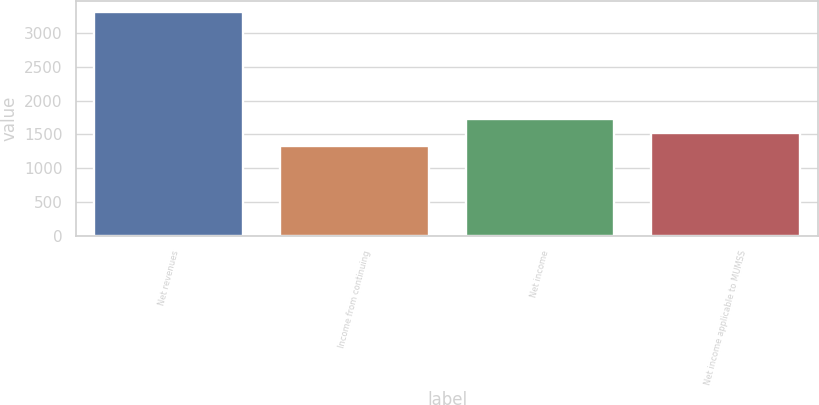Convert chart to OTSL. <chart><loc_0><loc_0><loc_500><loc_500><bar_chart><fcel>Net revenues<fcel>Income from continuing<fcel>Net income<fcel>Net income applicable to MUMSS<nl><fcel>3305<fcel>1325<fcel>1721<fcel>1523<nl></chart> 